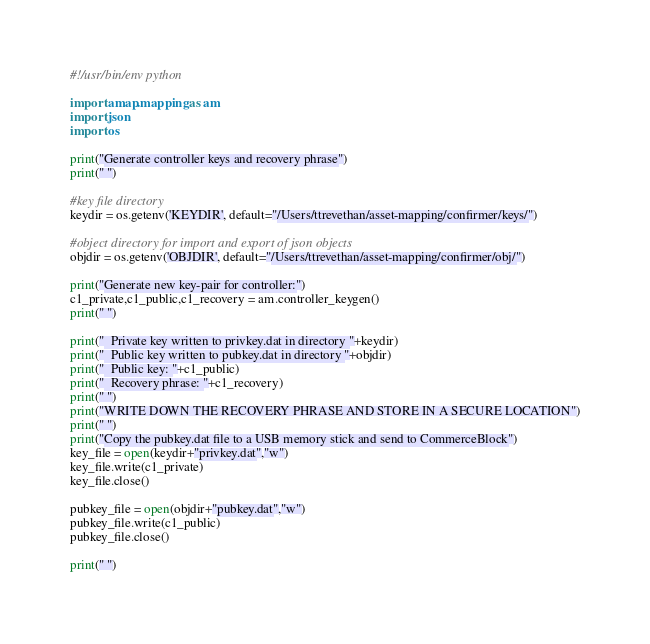<code> <loc_0><loc_0><loc_500><loc_500><_Python_>#!/usr/bin/env python

import amap.mapping as am
import json
import os

print("Generate controller keys and recovery phrase")
print(" ")

#key file directory
keydir = os.getenv('KEYDIR', default="/Users/ttrevethan/asset-mapping/confirmer/keys/")

#object directory for import and export of json objects
objdir = os.getenv('OBJDIR', default="/Users/ttrevethan/asset-mapping/confirmer/obj/")

print("Generate new key-pair for controller:")
c1_private,c1_public,c1_recovery = am.controller_keygen()
print(" ")

print("  Private key written to privkey.dat in directory "+keydir)
print("  Public key written to pubkey.dat in directory "+objdir)
print("  Public key: "+c1_public)
print("  Recovery phrase: "+c1_recovery)
print(" ")
print("WRITE DOWN THE RECOVERY PHRASE AND STORE IN A SECURE LOCATION")
print(" ")
print("Copy the pubkey.dat file to a USB memory stick and send to CommerceBlock")
key_file = open(keydir+"privkey.dat","w")
key_file.write(c1_private)
key_file.close()

pubkey_file = open(objdir+"pubkey.dat","w")
pubkey_file.write(c1_public)
pubkey_file.close()

print(" ")
</code> 